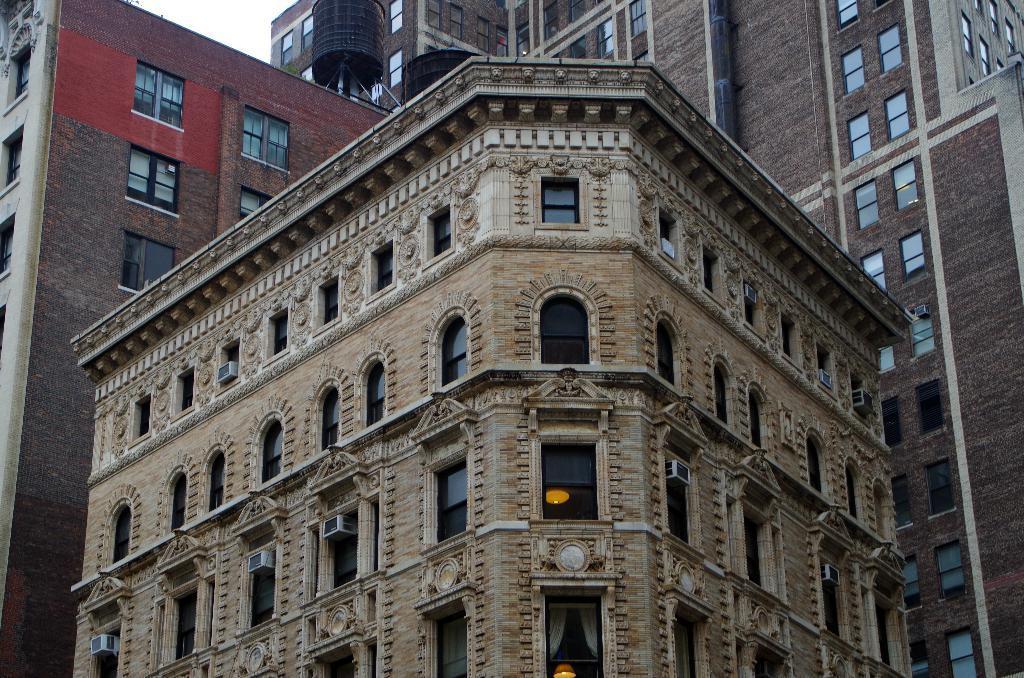How would you summarize this image in a sentence or two? In the picture there are few tall buildings and there are a lot of windows to those buildings. 